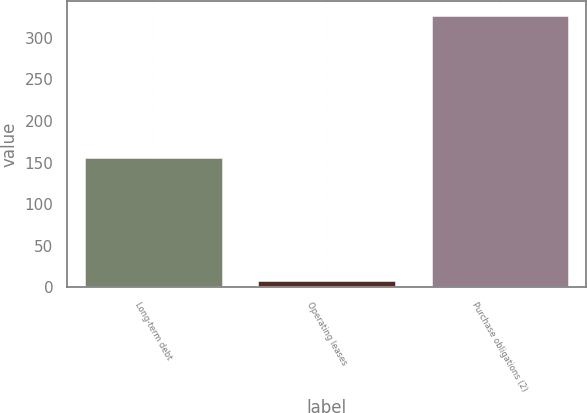Convert chart. <chart><loc_0><loc_0><loc_500><loc_500><bar_chart><fcel>Long-term debt<fcel>Operating leases<fcel>Purchase obligations (2)<nl><fcel>157<fcel>9<fcel>328<nl></chart> 